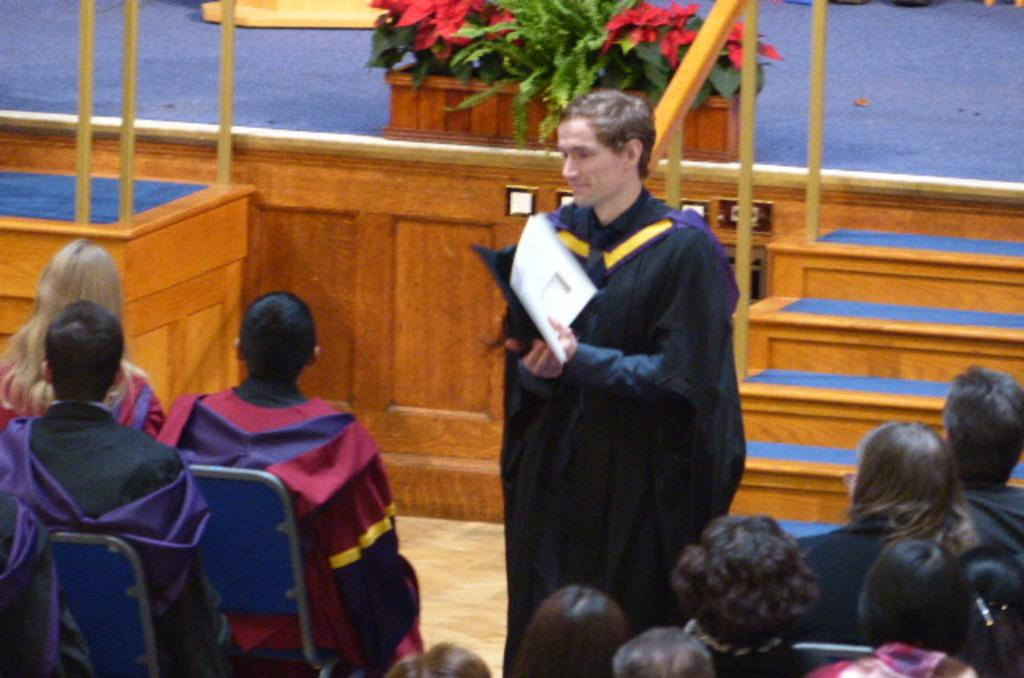What is the primary action of the person in the image? The person is standing in the image. What is the person holding in the image? The person is holding objects in the image. What is the position of the group of people in the image? The group of people is sitting in the image. What can be seen in the background of the image? There is a stage in the background of the image. What other objects are present in the image? There are additional objects present in the image. What type of stone is being used as a quill by the person on the stage in the image? There is no stone or quill present in the image, and there is no person on the stage. 